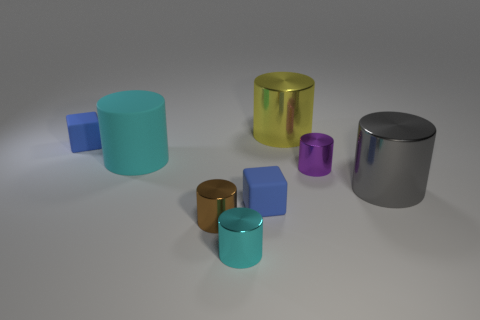Subtract all purple cylinders. How many cylinders are left? 5 Subtract all large gray cylinders. How many cylinders are left? 5 Subtract all green cylinders. Subtract all purple cubes. How many cylinders are left? 6 Add 1 brown shiny things. How many objects exist? 9 Subtract all cubes. How many objects are left? 6 Subtract 0 blue cylinders. How many objects are left? 8 Subtract all large gray objects. Subtract all tiny blue matte blocks. How many objects are left? 5 Add 3 big yellow cylinders. How many big yellow cylinders are left? 4 Add 5 cyan things. How many cyan things exist? 7 